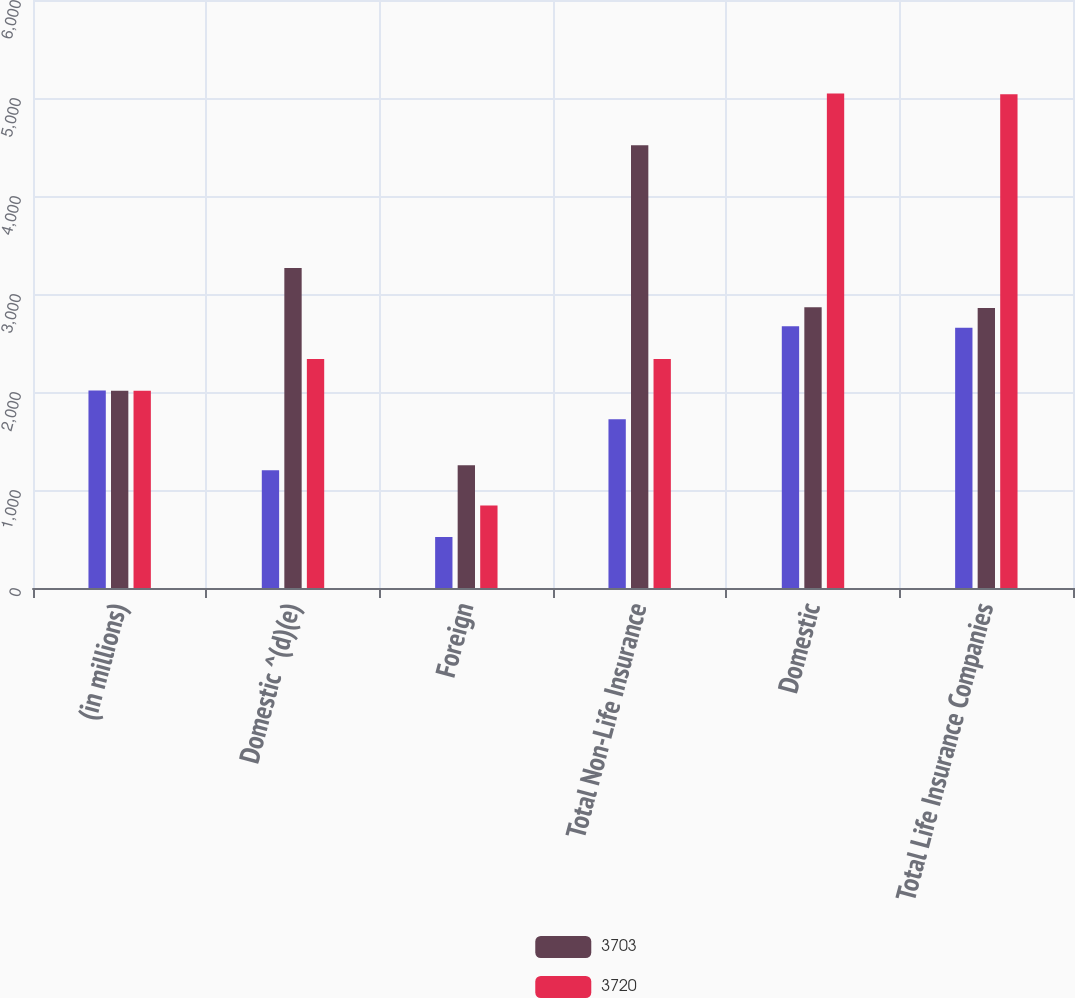<chart> <loc_0><loc_0><loc_500><loc_500><stacked_bar_chart><ecel><fcel>(in millions)<fcel>Domestic ^(d)(e)<fcel>Foreign<fcel>Total Non-Life Insurance<fcel>Domestic<fcel>Total Life Insurance Companies<nl><fcel>nan<fcel>2015<fcel>1202<fcel>521<fcel>1723<fcel>2672<fcel>2656<nl><fcel>3703<fcel>2014<fcel>3265<fcel>1252<fcel>4517<fcel>2865<fcel>2856<nl><fcel>3720<fcel>2013<fcel>2335.5<fcel>842<fcel>2335.5<fcel>5047<fcel>5038<nl></chart> 